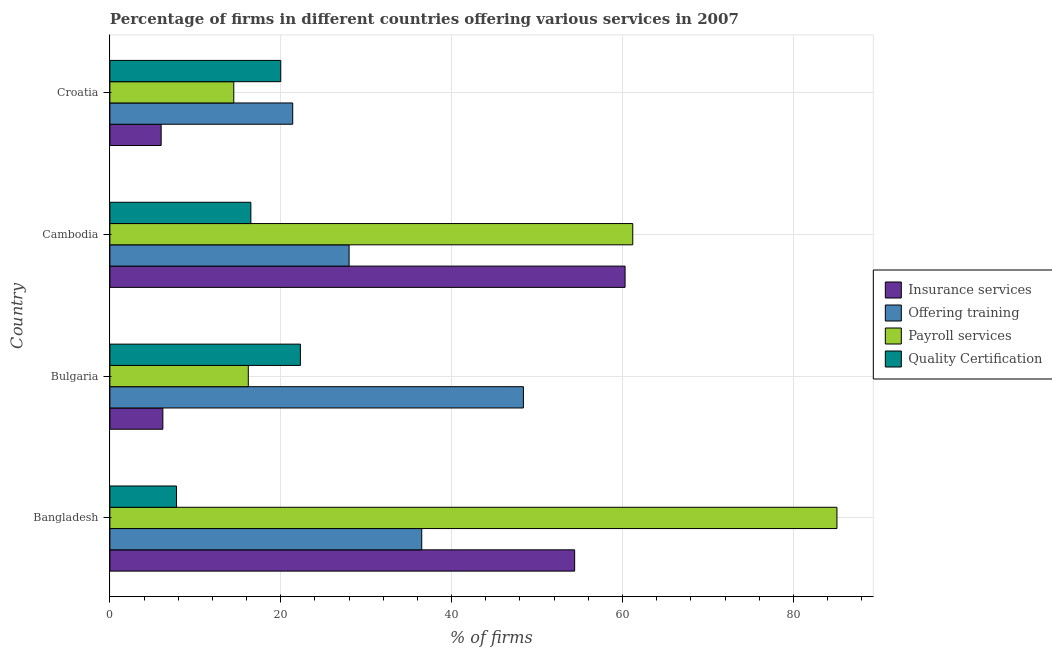How many groups of bars are there?
Provide a succinct answer. 4. Are the number of bars per tick equal to the number of legend labels?
Your answer should be compact. Yes. How many bars are there on the 4th tick from the top?
Provide a short and direct response. 4. What is the label of the 2nd group of bars from the top?
Provide a short and direct response. Cambodia. What is the percentage of firms offering payroll services in Bangladesh?
Your response must be concise. 85.1. Across all countries, what is the maximum percentage of firms offering payroll services?
Offer a terse response. 85.1. Across all countries, what is the minimum percentage of firms offering insurance services?
Your answer should be compact. 6. In which country was the percentage of firms offering training maximum?
Give a very brief answer. Bulgaria. In which country was the percentage of firms offering payroll services minimum?
Your answer should be compact. Croatia. What is the total percentage of firms offering training in the graph?
Your response must be concise. 134.3. What is the difference between the percentage of firms offering payroll services in Bulgaria and the percentage of firms offering quality certification in Cambodia?
Your answer should be compact. -0.3. What is the average percentage of firms offering insurance services per country?
Your answer should be very brief. 31.73. What is the difference between the percentage of firms offering payroll services and percentage of firms offering insurance services in Cambodia?
Provide a short and direct response. 0.9. In how many countries, is the percentage of firms offering payroll services greater than 36 %?
Offer a terse response. 2. What is the ratio of the percentage of firms offering training in Bulgaria to that in Croatia?
Keep it short and to the point. 2.26. Is the percentage of firms offering insurance services in Bulgaria less than that in Cambodia?
Keep it short and to the point. Yes. Is the difference between the percentage of firms offering insurance services in Bangladesh and Bulgaria greater than the difference between the percentage of firms offering quality certification in Bangladesh and Bulgaria?
Your answer should be compact. Yes. What is the difference between the highest and the lowest percentage of firms offering insurance services?
Provide a succinct answer. 54.3. Is the sum of the percentage of firms offering payroll services in Bangladesh and Cambodia greater than the maximum percentage of firms offering insurance services across all countries?
Your answer should be very brief. Yes. What does the 4th bar from the top in Cambodia represents?
Your response must be concise. Insurance services. What does the 4th bar from the bottom in Bangladesh represents?
Keep it short and to the point. Quality Certification. Is it the case that in every country, the sum of the percentage of firms offering insurance services and percentage of firms offering training is greater than the percentage of firms offering payroll services?
Provide a short and direct response. Yes. Are all the bars in the graph horizontal?
Ensure brevity in your answer.  Yes. Does the graph contain grids?
Your response must be concise. Yes. How are the legend labels stacked?
Provide a short and direct response. Vertical. What is the title of the graph?
Your answer should be very brief. Percentage of firms in different countries offering various services in 2007. Does "Compensation of employees" appear as one of the legend labels in the graph?
Ensure brevity in your answer.  No. What is the label or title of the X-axis?
Provide a succinct answer. % of firms. What is the label or title of the Y-axis?
Make the answer very short. Country. What is the % of firms in Insurance services in Bangladesh?
Offer a very short reply. 54.4. What is the % of firms in Offering training in Bangladesh?
Give a very brief answer. 36.5. What is the % of firms in Payroll services in Bangladesh?
Give a very brief answer. 85.1. What is the % of firms in Insurance services in Bulgaria?
Your response must be concise. 6.2. What is the % of firms of Offering training in Bulgaria?
Offer a very short reply. 48.4. What is the % of firms of Quality Certification in Bulgaria?
Ensure brevity in your answer.  22.3. What is the % of firms of Insurance services in Cambodia?
Make the answer very short. 60.3. What is the % of firms of Payroll services in Cambodia?
Give a very brief answer. 61.2. What is the % of firms of Quality Certification in Cambodia?
Your answer should be very brief. 16.5. What is the % of firms of Offering training in Croatia?
Your answer should be very brief. 21.4. What is the % of firms in Payroll services in Croatia?
Provide a succinct answer. 14.5. What is the % of firms in Quality Certification in Croatia?
Your answer should be compact. 20. Across all countries, what is the maximum % of firms in Insurance services?
Ensure brevity in your answer.  60.3. Across all countries, what is the maximum % of firms in Offering training?
Keep it short and to the point. 48.4. Across all countries, what is the maximum % of firms of Payroll services?
Offer a terse response. 85.1. Across all countries, what is the maximum % of firms of Quality Certification?
Your answer should be compact. 22.3. Across all countries, what is the minimum % of firms of Insurance services?
Your answer should be compact. 6. Across all countries, what is the minimum % of firms of Offering training?
Offer a terse response. 21.4. Across all countries, what is the minimum % of firms of Quality Certification?
Offer a terse response. 7.8. What is the total % of firms in Insurance services in the graph?
Your answer should be compact. 126.9. What is the total % of firms of Offering training in the graph?
Offer a very short reply. 134.3. What is the total % of firms in Payroll services in the graph?
Your response must be concise. 177. What is the total % of firms in Quality Certification in the graph?
Your response must be concise. 66.6. What is the difference between the % of firms of Insurance services in Bangladesh and that in Bulgaria?
Give a very brief answer. 48.2. What is the difference between the % of firms of Payroll services in Bangladesh and that in Bulgaria?
Ensure brevity in your answer.  68.9. What is the difference between the % of firms of Quality Certification in Bangladesh and that in Bulgaria?
Provide a succinct answer. -14.5. What is the difference between the % of firms of Offering training in Bangladesh and that in Cambodia?
Your answer should be very brief. 8.5. What is the difference between the % of firms of Payroll services in Bangladesh and that in Cambodia?
Provide a short and direct response. 23.9. What is the difference between the % of firms of Quality Certification in Bangladesh and that in Cambodia?
Provide a short and direct response. -8.7. What is the difference between the % of firms of Insurance services in Bangladesh and that in Croatia?
Your answer should be compact. 48.4. What is the difference between the % of firms of Offering training in Bangladesh and that in Croatia?
Make the answer very short. 15.1. What is the difference between the % of firms of Payroll services in Bangladesh and that in Croatia?
Ensure brevity in your answer.  70.6. What is the difference between the % of firms of Quality Certification in Bangladesh and that in Croatia?
Your answer should be compact. -12.2. What is the difference between the % of firms of Insurance services in Bulgaria and that in Cambodia?
Ensure brevity in your answer.  -54.1. What is the difference between the % of firms of Offering training in Bulgaria and that in Cambodia?
Offer a very short reply. 20.4. What is the difference between the % of firms of Payroll services in Bulgaria and that in Cambodia?
Your answer should be very brief. -45. What is the difference between the % of firms in Quality Certification in Bulgaria and that in Cambodia?
Give a very brief answer. 5.8. What is the difference between the % of firms of Offering training in Bulgaria and that in Croatia?
Your response must be concise. 27. What is the difference between the % of firms in Quality Certification in Bulgaria and that in Croatia?
Offer a terse response. 2.3. What is the difference between the % of firms in Insurance services in Cambodia and that in Croatia?
Give a very brief answer. 54.3. What is the difference between the % of firms of Payroll services in Cambodia and that in Croatia?
Your answer should be very brief. 46.7. What is the difference between the % of firms in Insurance services in Bangladesh and the % of firms in Offering training in Bulgaria?
Offer a terse response. 6. What is the difference between the % of firms in Insurance services in Bangladesh and the % of firms in Payroll services in Bulgaria?
Give a very brief answer. 38.2. What is the difference between the % of firms in Insurance services in Bangladesh and the % of firms in Quality Certification in Bulgaria?
Make the answer very short. 32.1. What is the difference between the % of firms of Offering training in Bangladesh and the % of firms of Payroll services in Bulgaria?
Make the answer very short. 20.3. What is the difference between the % of firms of Offering training in Bangladesh and the % of firms of Quality Certification in Bulgaria?
Give a very brief answer. 14.2. What is the difference between the % of firms in Payroll services in Bangladesh and the % of firms in Quality Certification in Bulgaria?
Your answer should be very brief. 62.8. What is the difference between the % of firms in Insurance services in Bangladesh and the % of firms in Offering training in Cambodia?
Keep it short and to the point. 26.4. What is the difference between the % of firms of Insurance services in Bangladesh and the % of firms of Payroll services in Cambodia?
Keep it short and to the point. -6.8. What is the difference between the % of firms in Insurance services in Bangladesh and the % of firms in Quality Certification in Cambodia?
Provide a succinct answer. 37.9. What is the difference between the % of firms of Offering training in Bangladesh and the % of firms of Payroll services in Cambodia?
Give a very brief answer. -24.7. What is the difference between the % of firms in Payroll services in Bangladesh and the % of firms in Quality Certification in Cambodia?
Your response must be concise. 68.6. What is the difference between the % of firms of Insurance services in Bangladesh and the % of firms of Payroll services in Croatia?
Ensure brevity in your answer.  39.9. What is the difference between the % of firms of Insurance services in Bangladesh and the % of firms of Quality Certification in Croatia?
Provide a succinct answer. 34.4. What is the difference between the % of firms of Payroll services in Bangladesh and the % of firms of Quality Certification in Croatia?
Your response must be concise. 65.1. What is the difference between the % of firms in Insurance services in Bulgaria and the % of firms in Offering training in Cambodia?
Ensure brevity in your answer.  -21.8. What is the difference between the % of firms of Insurance services in Bulgaria and the % of firms of Payroll services in Cambodia?
Provide a short and direct response. -55. What is the difference between the % of firms of Insurance services in Bulgaria and the % of firms of Quality Certification in Cambodia?
Provide a succinct answer. -10.3. What is the difference between the % of firms of Offering training in Bulgaria and the % of firms of Payroll services in Cambodia?
Your answer should be very brief. -12.8. What is the difference between the % of firms of Offering training in Bulgaria and the % of firms of Quality Certification in Cambodia?
Your answer should be very brief. 31.9. What is the difference between the % of firms in Insurance services in Bulgaria and the % of firms in Offering training in Croatia?
Your answer should be very brief. -15.2. What is the difference between the % of firms of Offering training in Bulgaria and the % of firms of Payroll services in Croatia?
Give a very brief answer. 33.9. What is the difference between the % of firms of Offering training in Bulgaria and the % of firms of Quality Certification in Croatia?
Ensure brevity in your answer.  28.4. What is the difference between the % of firms of Insurance services in Cambodia and the % of firms of Offering training in Croatia?
Give a very brief answer. 38.9. What is the difference between the % of firms in Insurance services in Cambodia and the % of firms in Payroll services in Croatia?
Provide a succinct answer. 45.8. What is the difference between the % of firms in Insurance services in Cambodia and the % of firms in Quality Certification in Croatia?
Ensure brevity in your answer.  40.3. What is the difference between the % of firms of Payroll services in Cambodia and the % of firms of Quality Certification in Croatia?
Provide a short and direct response. 41.2. What is the average % of firms of Insurance services per country?
Provide a succinct answer. 31.73. What is the average % of firms in Offering training per country?
Keep it short and to the point. 33.58. What is the average % of firms of Payroll services per country?
Your answer should be very brief. 44.25. What is the average % of firms of Quality Certification per country?
Ensure brevity in your answer.  16.65. What is the difference between the % of firms in Insurance services and % of firms in Offering training in Bangladesh?
Provide a short and direct response. 17.9. What is the difference between the % of firms in Insurance services and % of firms in Payroll services in Bangladesh?
Keep it short and to the point. -30.7. What is the difference between the % of firms in Insurance services and % of firms in Quality Certification in Bangladesh?
Your answer should be compact. 46.6. What is the difference between the % of firms in Offering training and % of firms in Payroll services in Bangladesh?
Your answer should be compact. -48.6. What is the difference between the % of firms in Offering training and % of firms in Quality Certification in Bangladesh?
Provide a succinct answer. 28.7. What is the difference between the % of firms of Payroll services and % of firms of Quality Certification in Bangladesh?
Provide a short and direct response. 77.3. What is the difference between the % of firms of Insurance services and % of firms of Offering training in Bulgaria?
Keep it short and to the point. -42.2. What is the difference between the % of firms of Insurance services and % of firms of Payroll services in Bulgaria?
Ensure brevity in your answer.  -10. What is the difference between the % of firms of Insurance services and % of firms of Quality Certification in Bulgaria?
Your answer should be very brief. -16.1. What is the difference between the % of firms in Offering training and % of firms in Payroll services in Bulgaria?
Give a very brief answer. 32.2. What is the difference between the % of firms of Offering training and % of firms of Quality Certification in Bulgaria?
Ensure brevity in your answer.  26.1. What is the difference between the % of firms in Insurance services and % of firms in Offering training in Cambodia?
Offer a terse response. 32.3. What is the difference between the % of firms in Insurance services and % of firms in Payroll services in Cambodia?
Provide a short and direct response. -0.9. What is the difference between the % of firms in Insurance services and % of firms in Quality Certification in Cambodia?
Offer a terse response. 43.8. What is the difference between the % of firms in Offering training and % of firms in Payroll services in Cambodia?
Your answer should be very brief. -33.2. What is the difference between the % of firms in Offering training and % of firms in Quality Certification in Cambodia?
Your response must be concise. 11.5. What is the difference between the % of firms of Payroll services and % of firms of Quality Certification in Cambodia?
Offer a very short reply. 44.7. What is the difference between the % of firms of Insurance services and % of firms of Offering training in Croatia?
Provide a short and direct response. -15.4. What is the difference between the % of firms in Insurance services and % of firms in Quality Certification in Croatia?
Offer a terse response. -14. What is the difference between the % of firms in Payroll services and % of firms in Quality Certification in Croatia?
Your response must be concise. -5.5. What is the ratio of the % of firms of Insurance services in Bangladesh to that in Bulgaria?
Offer a very short reply. 8.77. What is the ratio of the % of firms of Offering training in Bangladesh to that in Bulgaria?
Make the answer very short. 0.75. What is the ratio of the % of firms of Payroll services in Bangladesh to that in Bulgaria?
Your response must be concise. 5.25. What is the ratio of the % of firms in Quality Certification in Bangladesh to that in Bulgaria?
Offer a terse response. 0.35. What is the ratio of the % of firms of Insurance services in Bangladesh to that in Cambodia?
Ensure brevity in your answer.  0.9. What is the ratio of the % of firms of Offering training in Bangladesh to that in Cambodia?
Offer a very short reply. 1.3. What is the ratio of the % of firms of Payroll services in Bangladesh to that in Cambodia?
Your response must be concise. 1.39. What is the ratio of the % of firms of Quality Certification in Bangladesh to that in Cambodia?
Your response must be concise. 0.47. What is the ratio of the % of firms in Insurance services in Bangladesh to that in Croatia?
Your answer should be compact. 9.07. What is the ratio of the % of firms in Offering training in Bangladesh to that in Croatia?
Offer a terse response. 1.71. What is the ratio of the % of firms in Payroll services in Bangladesh to that in Croatia?
Ensure brevity in your answer.  5.87. What is the ratio of the % of firms of Quality Certification in Bangladesh to that in Croatia?
Make the answer very short. 0.39. What is the ratio of the % of firms of Insurance services in Bulgaria to that in Cambodia?
Make the answer very short. 0.1. What is the ratio of the % of firms of Offering training in Bulgaria to that in Cambodia?
Keep it short and to the point. 1.73. What is the ratio of the % of firms of Payroll services in Bulgaria to that in Cambodia?
Make the answer very short. 0.26. What is the ratio of the % of firms of Quality Certification in Bulgaria to that in Cambodia?
Provide a short and direct response. 1.35. What is the ratio of the % of firms of Offering training in Bulgaria to that in Croatia?
Your answer should be compact. 2.26. What is the ratio of the % of firms of Payroll services in Bulgaria to that in Croatia?
Make the answer very short. 1.12. What is the ratio of the % of firms in Quality Certification in Bulgaria to that in Croatia?
Make the answer very short. 1.11. What is the ratio of the % of firms in Insurance services in Cambodia to that in Croatia?
Offer a very short reply. 10.05. What is the ratio of the % of firms of Offering training in Cambodia to that in Croatia?
Provide a short and direct response. 1.31. What is the ratio of the % of firms of Payroll services in Cambodia to that in Croatia?
Offer a terse response. 4.22. What is the ratio of the % of firms of Quality Certification in Cambodia to that in Croatia?
Your answer should be very brief. 0.82. What is the difference between the highest and the second highest % of firms in Offering training?
Your answer should be compact. 11.9. What is the difference between the highest and the second highest % of firms in Payroll services?
Your answer should be compact. 23.9. What is the difference between the highest and the lowest % of firms in Insurance services?
Provide a short and direct response. 54.3. What is the difference between the highest and the lowest % of firms in Offering training?
Your answer should be very brief. 27. What is the difference between the highest and the lowest % of firms in Payroll services?
Give a very brief answer. 70.6. What is the difference between the highest and the lowest % of firms in Quality Certification?
Keep it short and to the point. 14.5. 